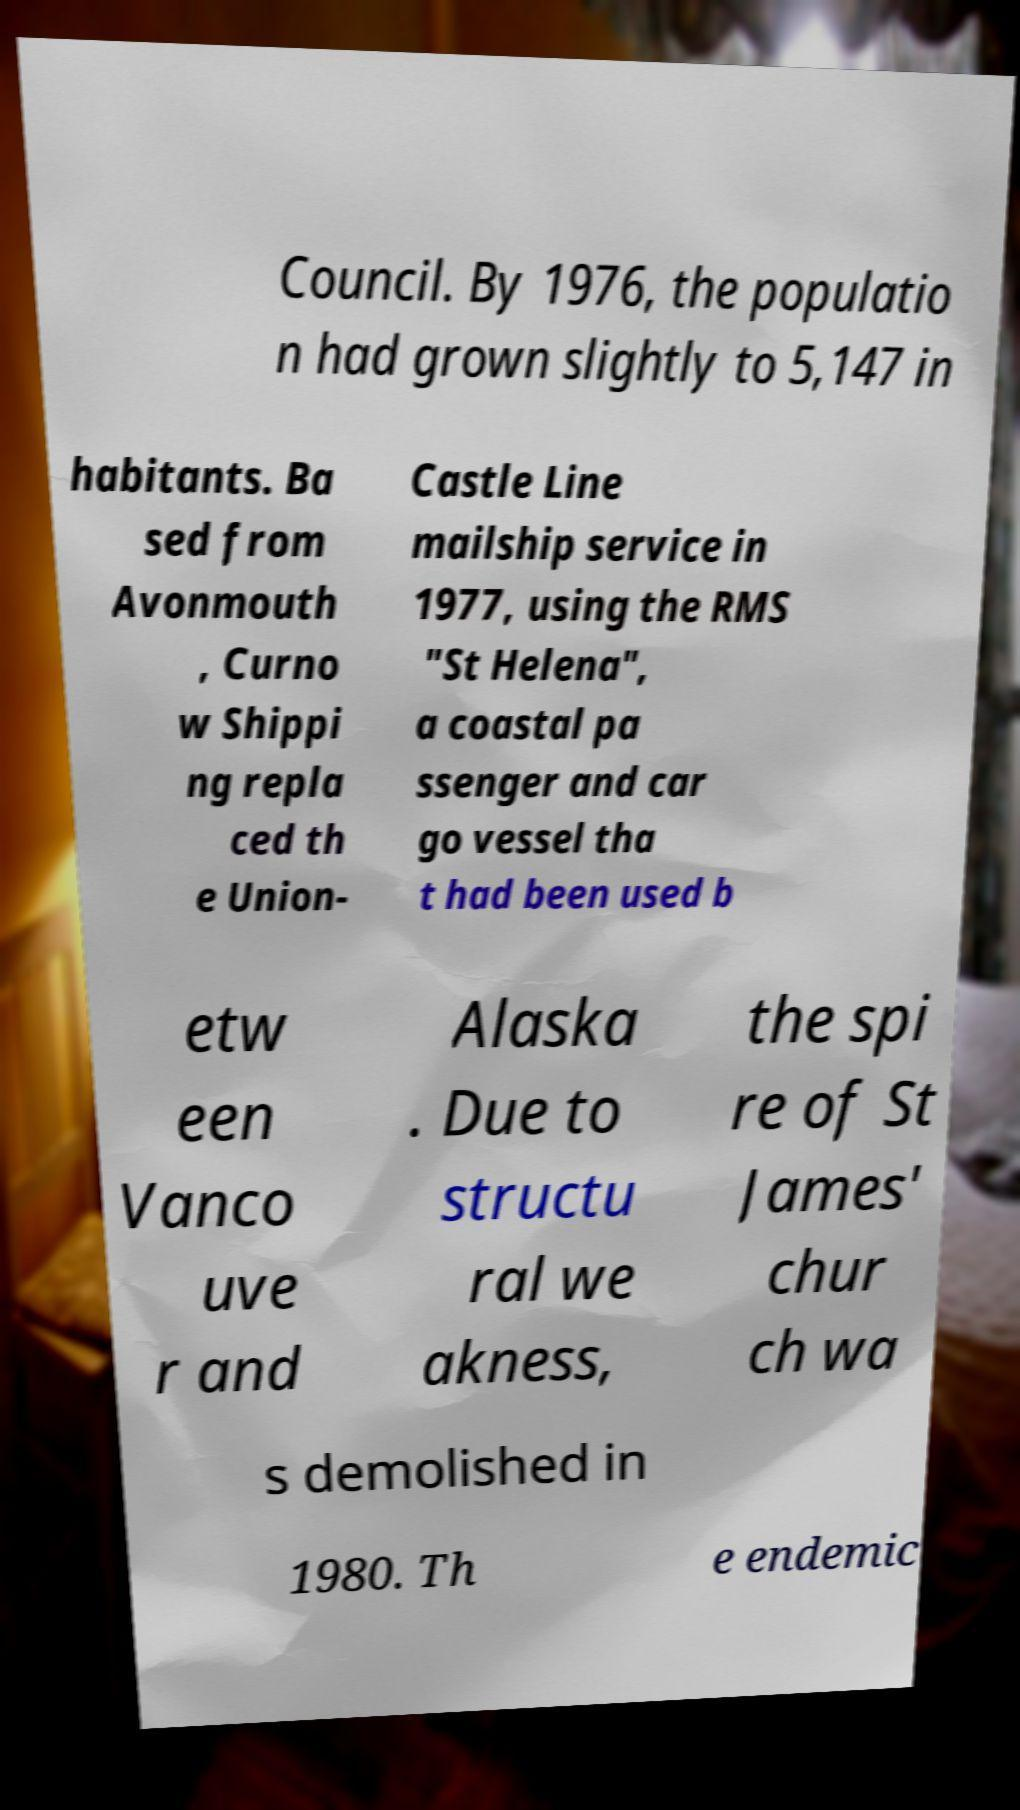Please read and relay the text visible in this image. What does it say? Council. By 1976, the populatio n had grown slightly to 5,147 in habitants. Ba sed from Avonmouth , Curno w Shippi ng repla ced th e Union- Castle Line mailship service in 1977, using the RMS "St Helena", a coastal pa ssenger and car go vessel tha t had been used b etw een Vanco uve r and Alaska . Due to structu ral we akness, the spi re of St James' chur ch wa s demolished in 1980. Th e endemic 